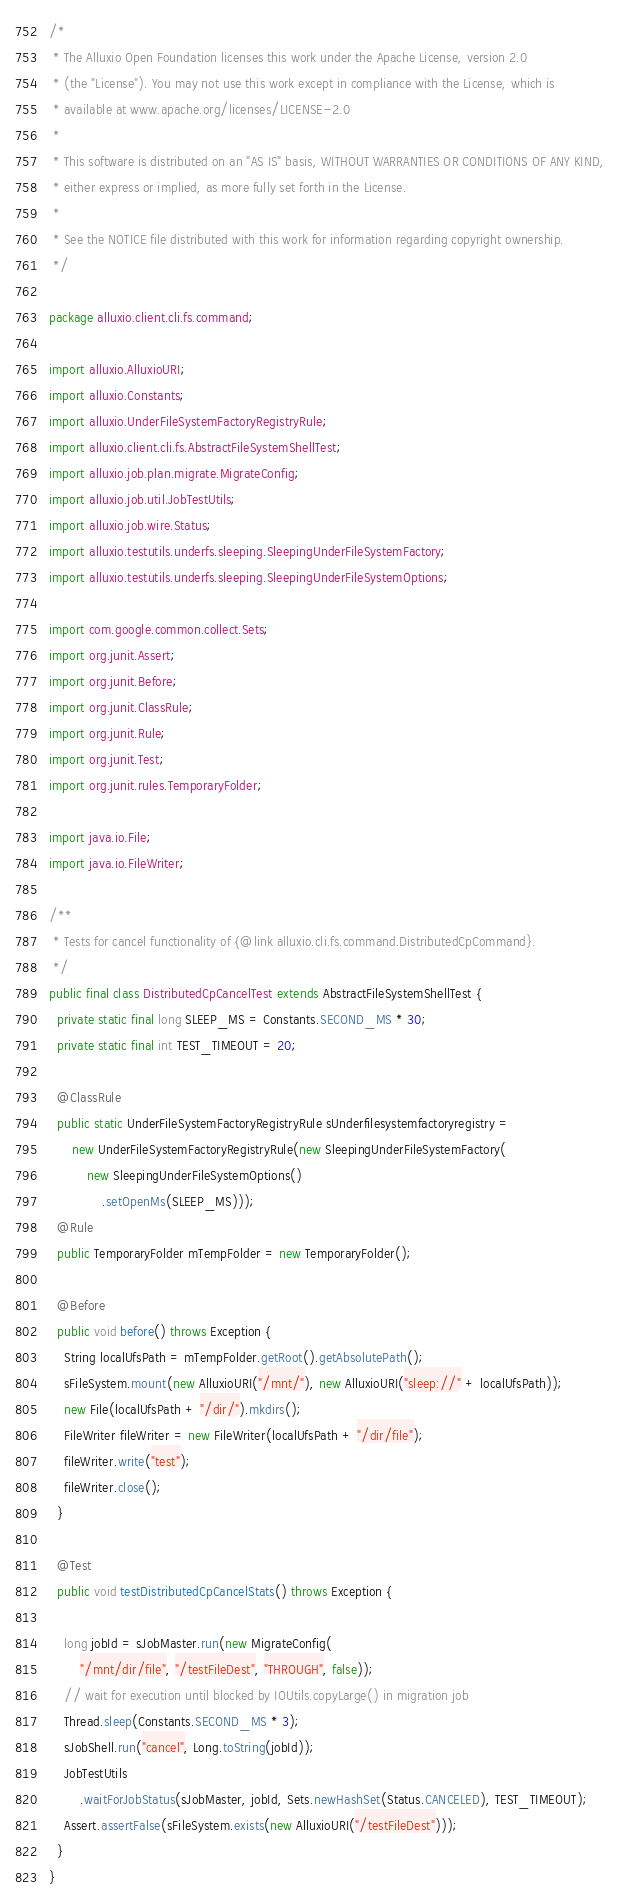<code> <loc_0><loc_0><loc_500><loc_500><_Java_>/*
 * The Alluxio Open Foundation licenses this work under the Apache License, version 2.0
 * (the "License"). You may not use this work except in compliance with the License, which is
 * available at www.apache.org/licenses/LICENSE-2.0
 *
 * This software is distributed on an "AS IS" basis, WITHOUT WARRANTIES OR CONDITIONS OF ANY KIND,
 * either express or implied, as more fully set forth in the License.
 *
 * See the NOTICE file distributed with this work for information regarding copyright ownership.
 */

package alluxio.client.cli.fs.command;

import alluxio.AlluxioURI;
import alluxio.Constants;
import alluxio.UnderFileSystemFactoryRegistryRule;
import alluxio.client.cli.fs.AbstractFileSystemShellTest;
import alluxio.job.plan.migrate.MigrateConfig;
import alluxio.job.util.JobTestUtils;
import alluxio.job.wire.Status;
import alluxio.testutils.underfs.sleeping.SleepingUnderFileSystemFactory;
import alluxio.testutils.underfs.sleeping.SleepingUnderFileSystemOptions;

import com.google.common.collect.Sets;
import org.junit.Assert;
import org.junit.Before;
import org.junit.ClassRule;
import org.junit.Rule;
import org.junit.Test;
import org.junit.rules.TemporaryFolder;

import java.io.File;
import java.io.FileWriter;

/**
 * Tests for cancel functionality of {@link alluxio.cli.fs.command.DistributedCpCommand}.
 */
public final class DistributedCpCancelTest extends AbstractFileSystemShellTest {
  private static final long SLEEP_MS = Constants.SECOND_MS * 30;
  private static final int TEST_TIMEOUT = 20;

  @ClassRule
  public static UnderFileSystemFactoryRegistryRule sUnderfilesystemfactoryregistry =
      new UnderFileSystemFactoryRegistryRule(new SleepingUnderFileSystemFactory(
          new SleepingUnderFileSystemOptions()
              .setOpenMs(SLEEP_MS)));
  @Rule
  public TemporaryFolder mTempFolder = new TemporaryFolder();

  @Before
  public void before() throws Exception {
    String localUfsPath = mTempFolder.getRoot().getAbsolutePath();
    sFileSystem.mount(new AlluxioURI("/mnt/"), new AlluxioURI("sleep://" + localUfsPath));
    new File(localUfsPath + "/dir/").mkdirs();
    FileWriter fileWriter = new FileWriter(localUfsPath + "/dir/file");
    fileWriter.write("test");
    fileWriter.close();
  }

  @Test
  public void testDistributedCpCancelStats() throws Exception {

    long jobId = sJobMaster.run(new MigrateConfig(
        "/mnt/dir/file", "/testFileDest", "THROUGH", false));
    // wait for execution until blocked by IOUtils.copyLarge() in migration job
    Thread.sleep(Constants.SECOND_MS * 3);
    sJobShell.run("cancel", Long.toString(jobId));
    JobTestUtils
        .waitForJobStatus(sJobMaster, jobId, Sets.newHashSet(Status.CANCELED), TEST_TIMEOUT);
    Assert.assertFalse(sFileSystem.exists(new AlluxioURI("/testFileDest")));
  }
}
</code> 